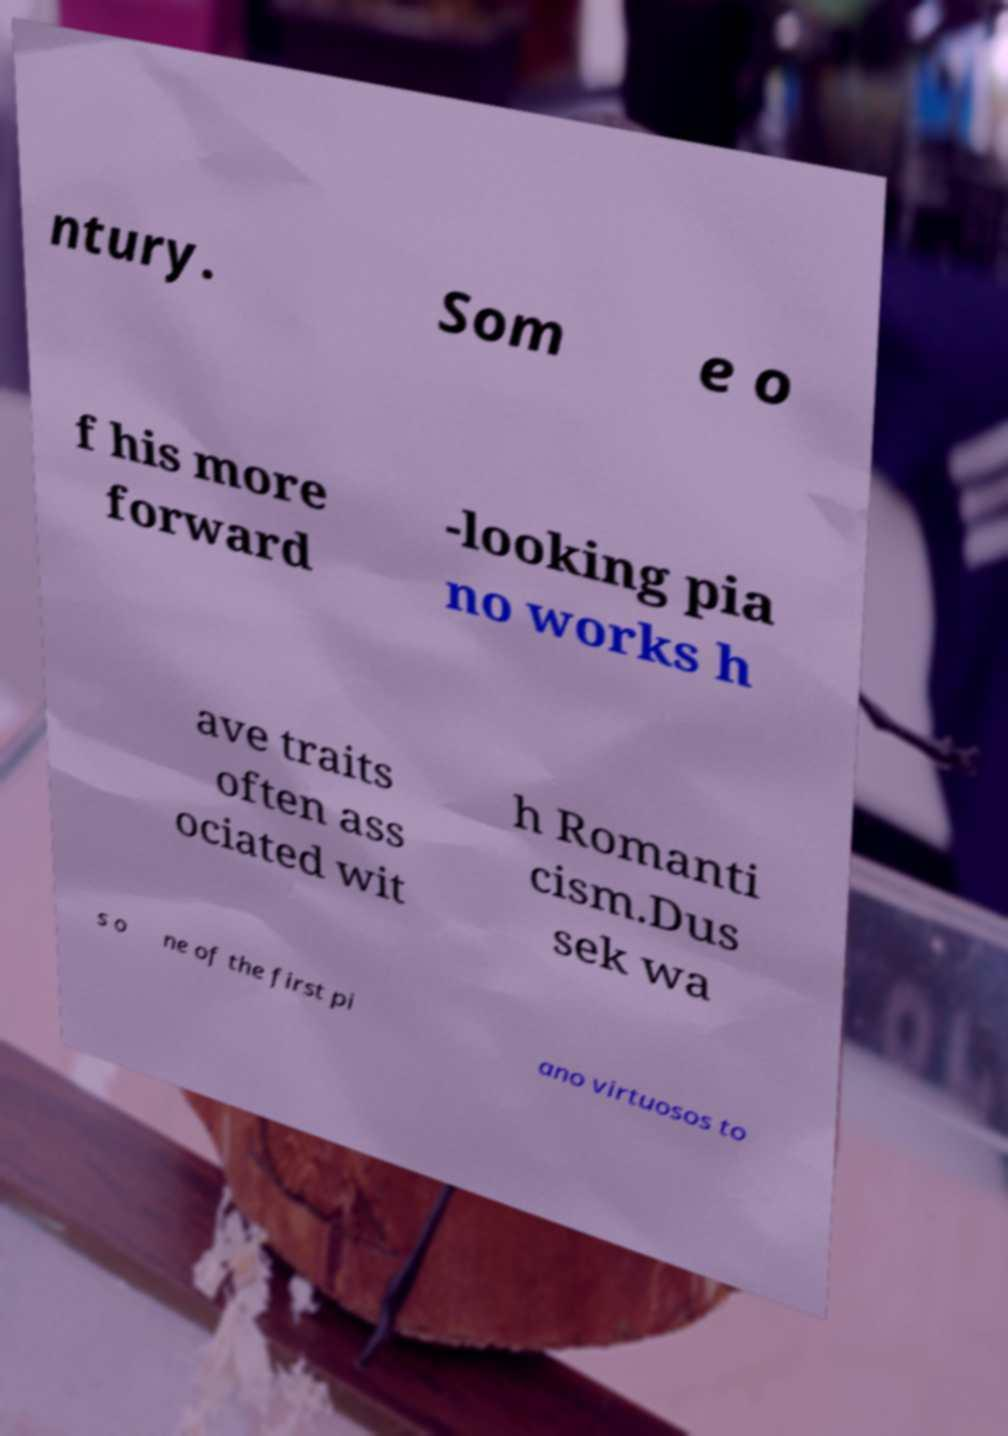Please read and relay the text visible in this image. What does it say? ntury. Som e o f his more forward -looking pia no works h ave traits often ass ociated wit h Romanti cism.Dus sek wa s o ne of the first pi ano virtuosos to 